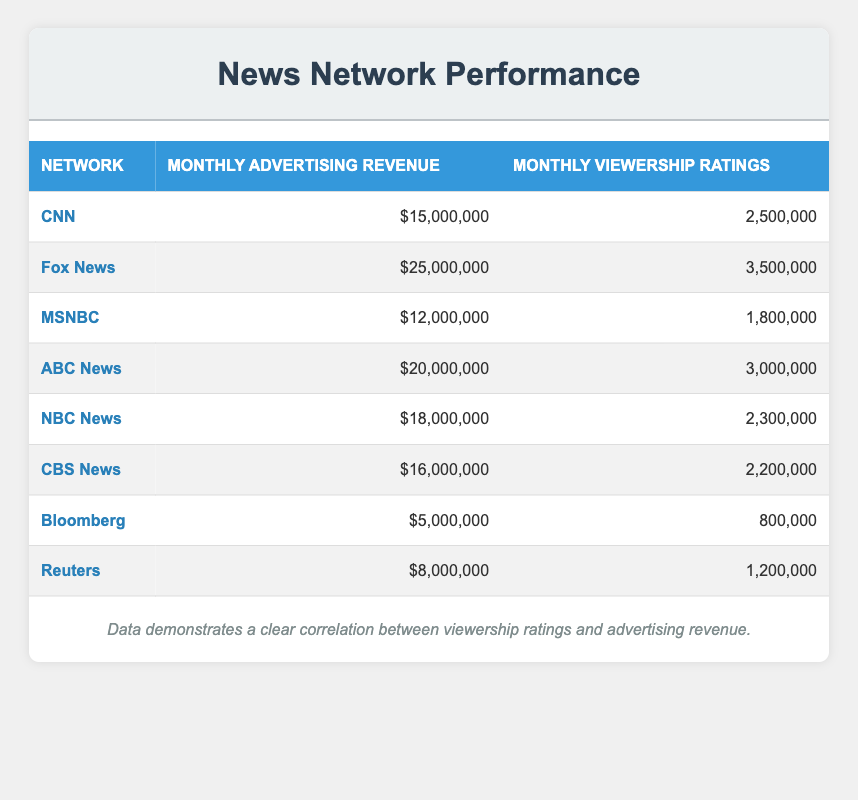What is the maximum amount of monthly advertising revenue recorded in the table? The maximum monthly advertising revenue can be found by reviewing the values in the "Monthly Advertising Revenue" column. The highest value from the data is for Fox News, which is $25,000,000.
Answer: 25,000,000 Which network has the lowest monthly viewership ratings? To find the network with the lowest monthly viewership ratings, I can look at the "Monthly Viewership Ratings" column and identify the smallest number. Bloomberg has the lowest rating at 800,000.
Answer: Bloomberg What is the total monthly advertising revenue for all networks combined? I will sum up the values from the "Monthly Advertising Revenue" column: 15,000,000 + 25,000,000 + 12,000,000 + 20,000,000 + 18,000,000 + 16,000,000 + 5,000,000 + 8,000,000 = 119,000,000.
Answer: 119,000,000 Is the statement true or false: ABC News has higher viewership ratings than CNN? I compare the viewership ratings of ABC News and CNN. ABC News has 3,000,000 while CNN has 2,500,000. Since 3,000,000 is greater than 2,500,000, the statement is true.
Answer: True What is the average monthly advertising revenue for networks that have viewership ratings over 2,500,000? I will first identify the networks with viewership ratings greater than 2,500,000, which are Fox News, ABC News, and CNN. Their advertising revenues are 25,000,000, 20,000,000, and 15,000,000 respectively. Then, I will sum these values: 25,000,000 + 20,000,000 + 15,000,000 = 60,000,000. Since there are three networks, I will divide by 3: 60,000,000 / 3 = 20,000,000.
Answer: 20,000,000 How many networks have monthly advertising revenue of more than $15,000,000? Reviewing the "Monthly Advertising Revenue" column, I can count the entries that are greater than $15,000,000. The networks that qualify are Fox News, ABC News, NBC News, CBS News, and CNN. That totals five networks.
Answer: 5 